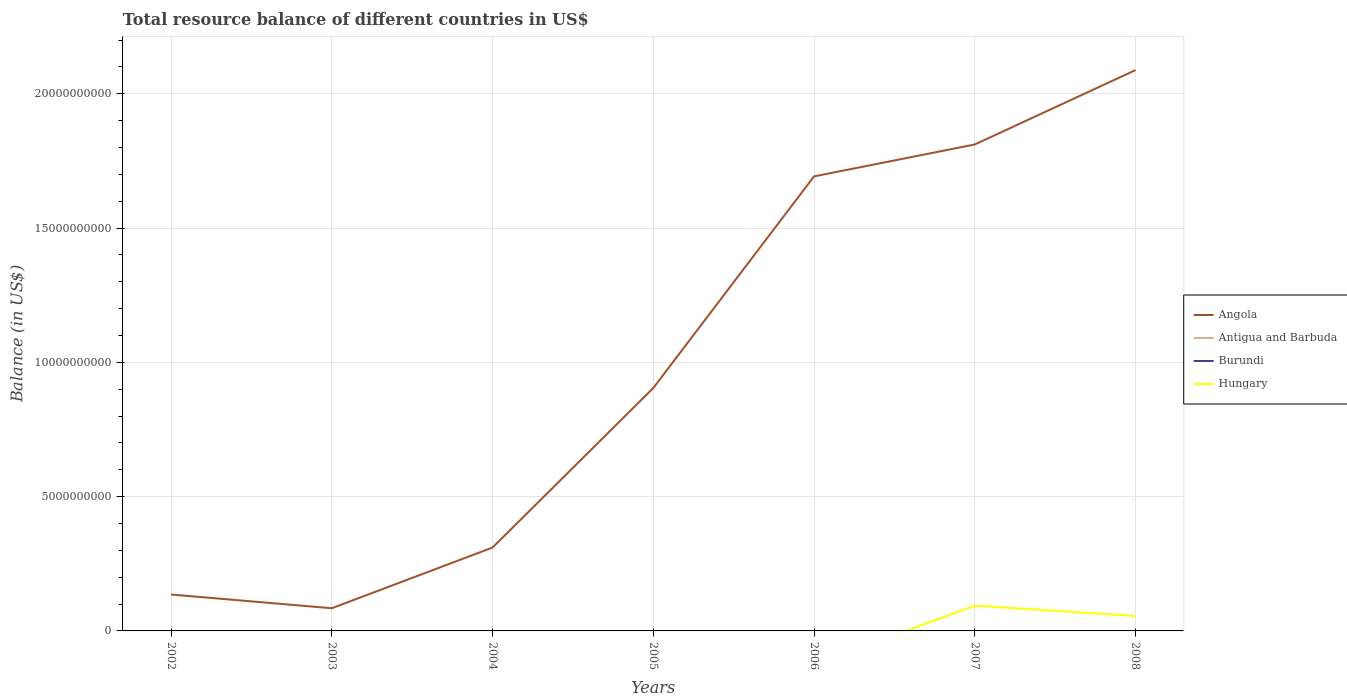How many different coloured lines are there?
Your answer should be very brief. 2. Does the line corresponding to Burundi intersect with the line corresponding to Hungary?
Provide a succinct answer. Yes. Is the number of lines equal to the number of legend labels?
Provide a succinct answer. No. Across all years, what is the maximum total resource balance in Antigua and Barbuda?
Keep it short and to the point. 0. What is the total total resource balance in Angola in the graph?
Ensure brevity in your answer.  -1.95e+1. What is the difference between the highest and the second highest total resource balance in Angola?
Provide a short and direct response. 2.00e+1. Is the total resource balance in Angola strictly greater than the total resource balance in Antigua and Barbuda over the years?
Keep it short and to the point. No. How many years are there in the graph?
Make the answer very short. 7. What is the difference between two consecutive major ticks on the Y-axis?
Ensure brevity in your answer.  5.00e+09. Are the values on the major ticks of Y-axis written in scientific E-notation?
Offer a terse response. No. Does the graph contain grids?
Keep it short and to the point. Yes. How many legend labels are there?
Your answer should be very brief. 4. How are the legend labels stacked?
Provide a succinct answer. Vertical. What is the title of the graph?
Give a very brief answer. Total resource balance of different countries in US$. What is the label or title of the X-axis?
Provide a succinct answer. Years. What is the label or title of the Y-axis?
Offer a very short reply. Balance (in US$). What is the Balance (in US$) in Angola in 2002?
Offer a very short reply. 1.36e+09. What is the Balance (in US$) in Antigua and Barbuda in 2002?
Offer a very short reply. 0. What is the Balance (in US$) of Hungary in 2002?
Your answer should be compact. 0. What is the Balance (in US$) in Angola in 2003?
Make the answer very short. 8.45e+08. What is the Balance (in US$) of Burundi in 2003?
Your answer should be very brief. 0. What is the Balance (in US$) in Angola in 2004?
Make the answer very short. 3.10e+09. What is the Balance (in US$) of Antigua and Barbuda in 2004?
Your answer should be compact. 0. What is the Balance (in US$) of Angola in 2005?
Offer a terse response. 9.04e+09. What is the Balance (in US$) in Hungary in 2005?
Provide a short and direct response. 0. What is the Balance (in US$) of Angola in 2006?
Provide a succinct answer. 1.69e+1. What is the Balance (in US$) in Antigua and Barbuda in 2006?
Your response must be concise. 0. What is the Balance (in US$) of Burundi in 2006?
Give a very brief answer. 0. What is the Balance (in US$) of Hungary in 2006?
Give a very brief answer. 0. What is the Balance (in US$) in Angola in 2007?
Your response must be concise. 1.81e+1. What is the Balance (in US$) in Antigua and Barbuda in 2007?
Ensure brevity in your answer.  0. What is the Balance (in US$) of Burundi in 2007?
Keep it short and to the point. 0. What is the Balance (in US$) of Hungary in 2007?
Offer a terse response. 9.41e+08. What is the Balance (in US$) of Angola in 2008?
Provide a short and direct response. 2.09e+1. What is the Balance (in US$) of Antigua and Barbuda in 2008?
Offer a very short reply. 0. What is the Balance (in US$) in Burundi in 2008?
Offer a terse response. 0. What is the Balance (in US$) of Hungary in 2008?
Keep it short and to the point. 5.55e+08. Across all years, what is the maximum Balance (in US$) in Angola?
Provide a succinct answer. 2.09e+1. Across all years, what is the maximum Balance (in US$) in Hungary?
Provide a short and direct response. 9.41e+08. Across all years, what is the minimum Balance (in US$) of Angola?
Ensure brevity in your answer.  8.45e+08. Across all years, what is the minimum Balance (in US$) of Hungary?
Provide a succinct answer. 0. What is the total Balance (in US$) in Angola in the graph?
Provide a short and direct response. 7.03e+1. What is the total Balance (in US$) of Burundi in the graph?
Provide a short and direct response. 0. What is the total Balance (in US$) of Hungary in the graph?
Offer a terse response. 1.50e+09. What is the difference between the Balance (in US$) in Angola in 2002 and that in 2003?
Give a very brief answer. 5.11e+08. What is the difference between the Balance (in US$) in Angola in 2002 and that in 2004?
Give a very brief answer. -1.75e+09. What is the difference between the Balance (in US$) in Angola in 2002 and that in 2005?
Keep it short and to the point. -7.69e+09. What is the difference between the Balance (in US$) of Angola in 2002 and that in 2006?
Provide a short and direct response. -1.56e+1. What is the difference between the Balance (in US$) in Angola in 2002 and that in 2007?
Ensure brevity in your answer.  -1.68e+1. What is the difference between the Balance (in US$) of Angola in 2002 and that in 2008?
Ensure brevity in your answer.  -1.95e+1. What is the difference between the Balance (in US$) in Angola in 2003 and that in 2004?
Offer a terse response. -2.26e+09. What is the difference between the Balance (in US$) of Angola in 2003 and that in 2005?
Offer a terse response. -8.20e+09. What is the difference between the Balance (in US$) in Angola in 2003 and that in 2006?
Offer a terse response. -1.61e+1. What is the difference between the Balance (in US$) in Angola in 2003 and that in 2007?
Keep it short and to the point. -1.73e+1. What is the difference between the Balance (in US$) of Angola in 2003 and that in 2008?
Your response must be concise. -2.00e+1. What is the difference between the Balance (in US$) in Angola in 2004 and that in 2005?
Your answer should be very brief. -5.94e+09. What is the difference between the Balance (in US$) in Angola in 2004 and that in 2006?
Keep it short and to the point. -1.38e+1. What is the difference between the Balance (in US$) in Angola in 2004 and that in 2007?
Provide a short and direct response. -1.50e+1. What is the difference between the Balance (in US$) in Angola in 2004 and that in 2008?
Make the answer very short. -1.78e+1. What is the difference between the Balance (in US$) in Angola in 2005 and that in 2006?
Provide a short and direct response. -7.88e+09. What is the difference between the Balance (in US$) in Angola in 2005 and that in 2007?
Ensure brevity in your answer.  -9.07e+09. What is the difference between the Balance (in US$) in Angola in 2005 and that in 2008?
Offer a very short reply. -1.18e+1. What is the difference between the Balance (in US$) in Angola in 2006 and that in 2007?
Provide a succinct answer. -1.19e+09. What is the difference between the Balance (in US$) of Angola in 2006 and that in 2008?
Your response must be concise. -3.96e+09. What is the difference between the Balance (in US$) of Angola in 2007 and that in 2008?
Your answer should be compact. -2.77e+09. What is the difference between the Balance (in US$) of Hungary in 2007 and that in 2008?
Make the answer very short. 3.87e+08. What is the difference between the Balance (in US$) of Angola in 2002 and the Balance (in US$) of Hungary in 2007?
Your answer should be very brief. 4.14e+08. What is the difference between the Balance (in US$) in Angola in 2002 and the Balance (in US$) in Hungary in 2008?
Provide a succinct answer. 8.01e+08. What is the difference between the Balance (in US$) of Angola in 2003 and the Balance (in US$) of Hungary in 2007?
Offer a terse response. -9.68e+07. What is the difference between the Balance (in US$) of Angola in 2003 and the Balance (in US$) of Hungary in 2008?
Make the answer very short. 2.90e+08. What is the difference between the Balance (in US$) in Angola in 2004 and the Balance (in US$) in Hungary in 2007?
Make the answer very short. 2.16e+09. What is the difference between the Balance (in US$) of Angola in 2004 and the Balance (in US$) of Hungary in 2008?
Your answer should be compact. 2.55e+09. What is the difference between the Balance (in US$) in Angola in 2005 and the Balance (in US$) in Hungary in 2007?
Give a very brief answer. 8.10e+09. What is the difference between the Balance (in US$) in Angola in 2005 and the Balance (in US$) in Hungary in 2008?
Provide a short and direct response. 8.49e+09. What is the difference between the Balance (in US$) in Angola in 2006 and the Balance (in US$) in Hungary in 2007?
Your answer should be very brief. 1.60e+1. What is the difference between the Balance (in US$) in Angola in 2006 and the Balance (in US$) in Hungary in 2008?
Provide a succinct answer. 1.64e+1. What is the difference between the Balance (in US$) in Angola in 2007 and the Balance (in US$) in Hungary in 2008?
Your answer should be compact. 1.76e+1. What is the average Balance (in US$) of Angola per year?
Provide a short and direct response. 1.00e+1. What is the average Balance (in US$) of Antigua and Barbuda per year?
Ensure brevity in your answer.  0. What is the average Balance (in US$) of Burundi per year?
Your response must be concise. 0. What is the average Balance (in US$) in Hungary per year?
Make the answer very short. 2.14e+08. In the year 2007, what is the difference between the Balance (in US$) in Angola and Balance (in US$) in Hungary?
Give a very brief answer. 1.72e+1. In the year 2008, what is the difference between the Balance (in US$) in Angola and Balance (in US$) in Hungary?
Your answer should be very brief. 2.03e+1. What is the ratio of the Balance (in US$) of Angola in 2002 to that in 2003?
Make the answer very short. 1.6. What is the ratio of the Balance (in US$) in Angola in 2002 to that in 2004?
Your answer should be compact. 0.44. What is the ratio of the Balance (in US$) of Angola in 2002 to that in 2005?
Your answer should be very brief. 0.15. What is the ratio of the Balance (in US$) of Angola in 2002 to that in 2006?
Offer a very short reply. 0.08. What is the ratio of the Balance (in US$) in Angola in 2002 to that in 2007?
Give a very brief answer. 0.07. What is the ratio of the Balance (in US$) of Angola in 2002 to that in 2008?
Keep it short and to the point. 0.06. What is the ratio of the Balance (in US$) of Angola in 2003 to that in 2004?
Offer a terse response. 0.27. What is the ratio of the Balance (in US$) in Angola in 2003 to that in 2005?
Give a very brief answer. 0.09. What is the ratio of the Balance (in US$) in Angola in 2003 to that in 2006?
Offer a terse response. 0.05. What is the ratio of the Balance (in US$) of Angola in 2003 to that in 2007?
Provide a succinct answer. 0.05. What is the ratio of the Balance (in US$) in Angola in 2003 to that in 2008?
Your answer should be very brief. 0.04. What is the ratio of the Balance (in US$) of Angola in 2004 to that in 2005?
Offer a terse response. 0.34. What is the ratio of the Balance (in US$) in Angola in 2004 to that in 2006?
Keep it short and to the point. 0.18. What is the ratio of the Balance (in US$) in Angola in 2004 to that in 2007?
Keep it short and to the point. 0.17. What is the ratio of the Balance (in US$) in Angola in 2004 to that in 2008?
Offer a terse response. 0.15. What is the ratio of the Balance (in US$) in Angola in 2005 to that in 2006?
Give a very brief answer. 0.53. What is the ratio of the Balance (in US$) of Angola in 2005 to that in 2007?
Offer a terse response. 0.5. What is the ratio of the Balance (in US$) of Angola in 2005 to that in 2008?
Ensure brevity in your answer.  0.43. What is the ratio of the Balance (in US$) of Angola in 2006 to that in 2007?
Ensure brevity in your answer.  0.93. What is the ratio of the Balance (in US$) of Angola in 2006 to that in 2008?
Give a very brief answer. 0.81. What is the ratio of the Balance (in US$) in Angola in 2007 to that in 2008?
Make the answer very short. 0.87. What is the ratio of the Balance (in US$) of Hungary in 2007 to that in 2008?
Your response must be concise. 1.7. What is the difference between the highest and the second highest Balance (in US$) in Angola?
Provide a short and direct response. 2.77e+09. What is the difference between the highest and the lowest Balance (in US$) of Angola?
Ensure brevity in your answer.  2.00e+1. What is the difference between the highest and the lowest Balance (in US$) in Hungary?
Provide a succinct answer. 9.41e+08. 